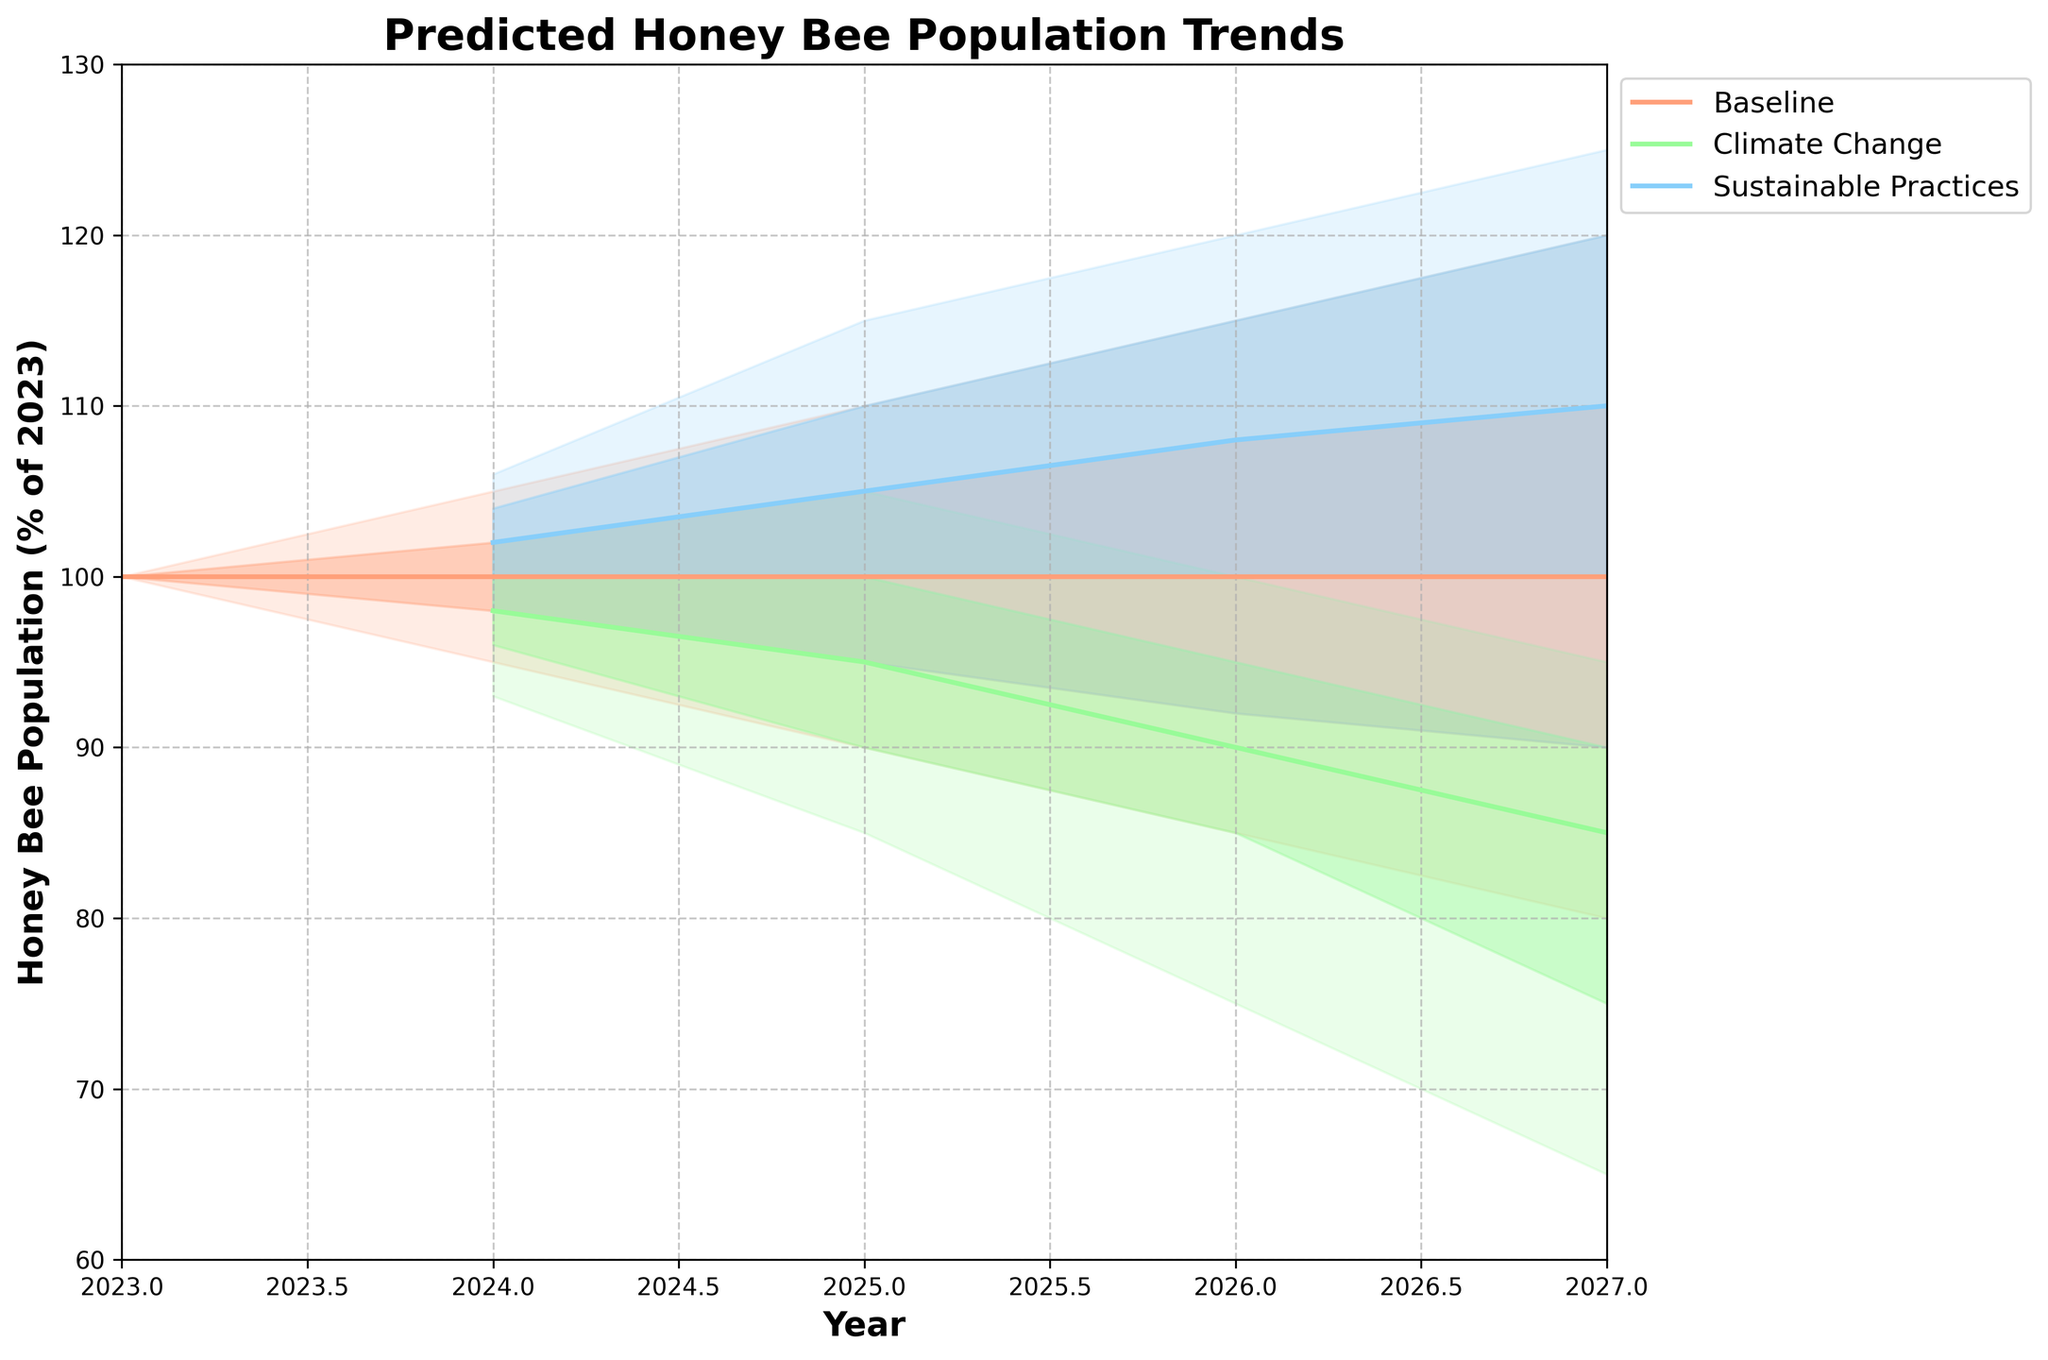What does the title of the chart indicate? The title indicates the primary purpose and focus of the chart, which is to show the predicted trends in the honey bee population under various environmental conditions.
Answer: Predicted Honey Bee Population Trends What are the three scenarios represented in the chart? There are three distinct scenarios shown in the chart, each marked by different colors to distinguish the predicted trends in the bee population under different circumstances.
Answer: Baseline, Climate Change, Sustainable Practices Which scenario depicts the highest median honey bee population in 2027? To determine this, look at the median lines for each scenario in 2027 and identify the highest value.
Answer: Sustainable Practices What is the range of the honey bee population in the "Baseline" scenario for the year 2026? The range can be found between the lower 10th and upper 90th percentiles for 2026 within the "Baseline" scenario.
Answer: 85 to 115 How does the median honey bee population in the "Climate Change" scenario change from 2024 to 2027? Trace the median line for the "Climate Change" scenario from 2024 to 2027 to observe the trend. The population decreases over this period.
Answer: Decreases from 98 to 85 In 2025, which scenario has the narrowest range between the lower 10th and upper 90th percentiles? Compare the ranges between the lower 10th and upper 90th percentiles for each scenario in 2025, and identify the smallest range.
Answer: Climate Change What can you infer about the sustainability impact on bee population from the chart? Compare the trends and ranges of the median values over the years for the "Sustainable Practices" scenario versus the "Baseline" and "Climate Change" scenarios.
Answer: Major positive impact In which year is the median population for the "Baseline" scenario exactly the same as it was in 2023? Look at the "Baseline" scenario's median line and compare it across the years to see where it matches the 2023 value.
Answer: 2024 What are the lower and upper boundaries of the "Sustainable Practices" scenario in 2027? Check the values of the lower 10th and upper 90th percentiles for the "Sustainable Practices" scenario in 2027.
Answer: 90 to 125 How does the predicted variability in bee population change under "Climate Change" from 2024 to 2027? Observe the width of the shaded regions (indicating variability) for the "Climate Change" scenario between 2024 and 2027. The range widens, showing increased variability.
Answer: Increases 